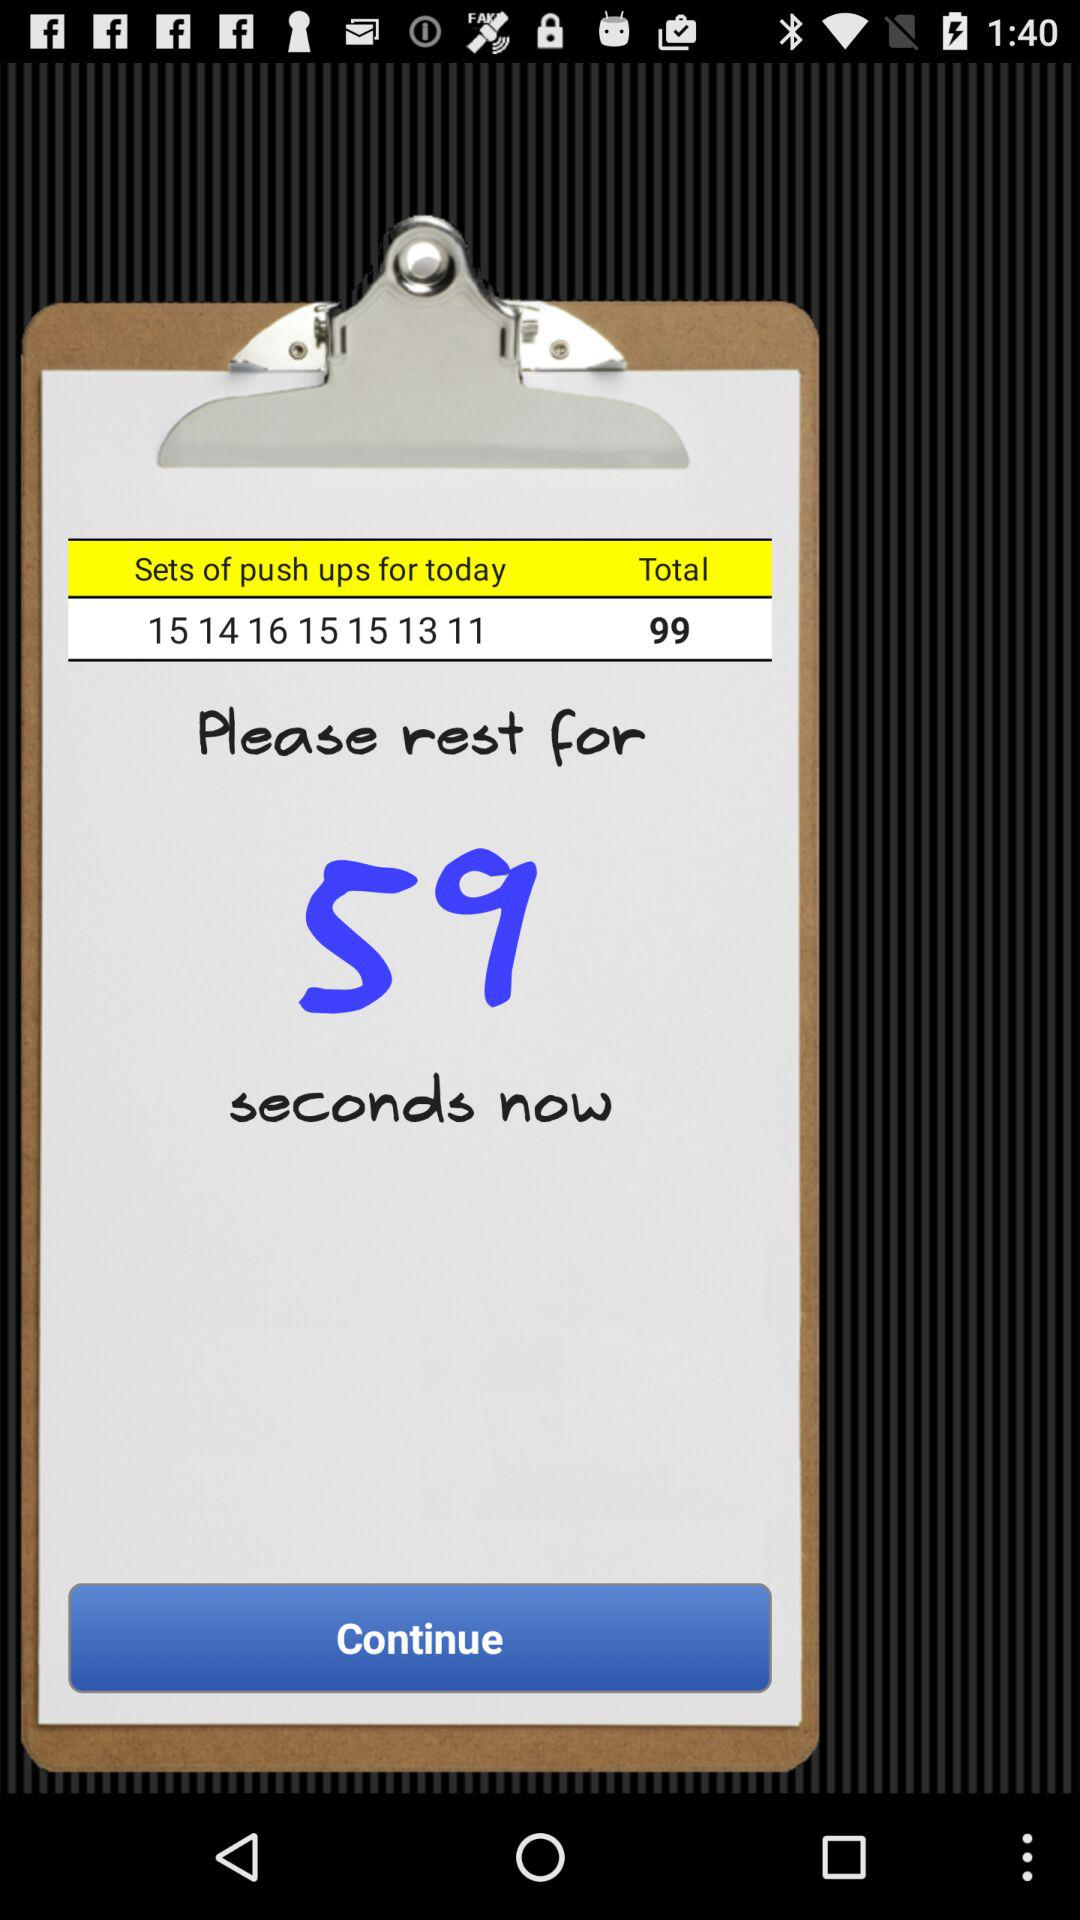How many sets of push ups are there?
Answer the question using a single word or phrase. 7 